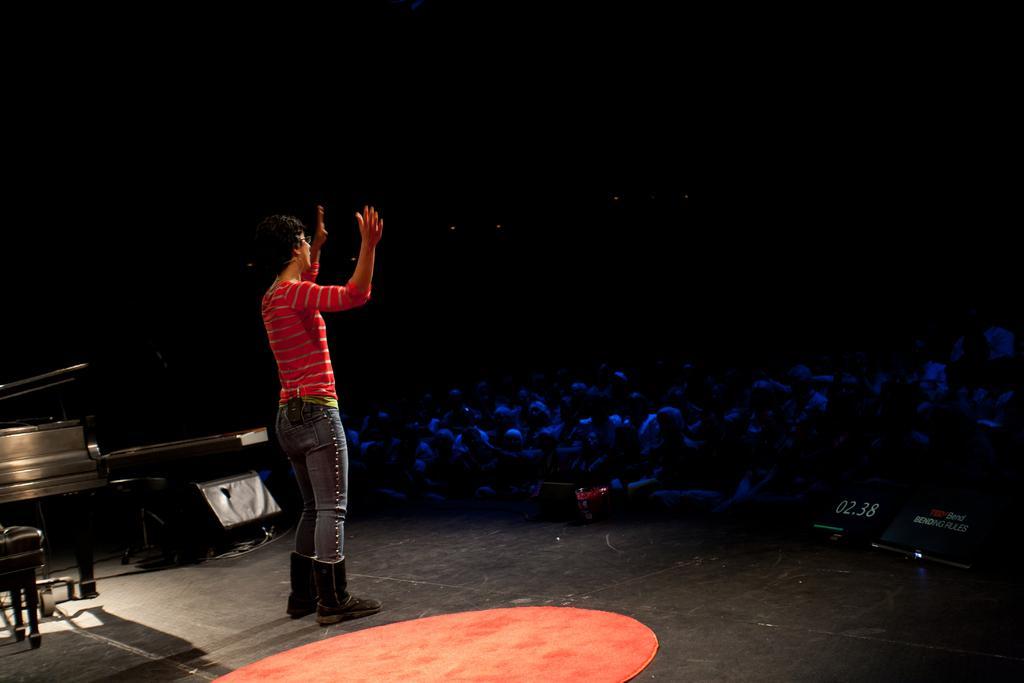How would you summarize this image in a sentence or two? There is a person who is standing on the floor. She is in a red color t shirt. These are some musical instruments. Here we can see some persons are sitting on the chairs. 